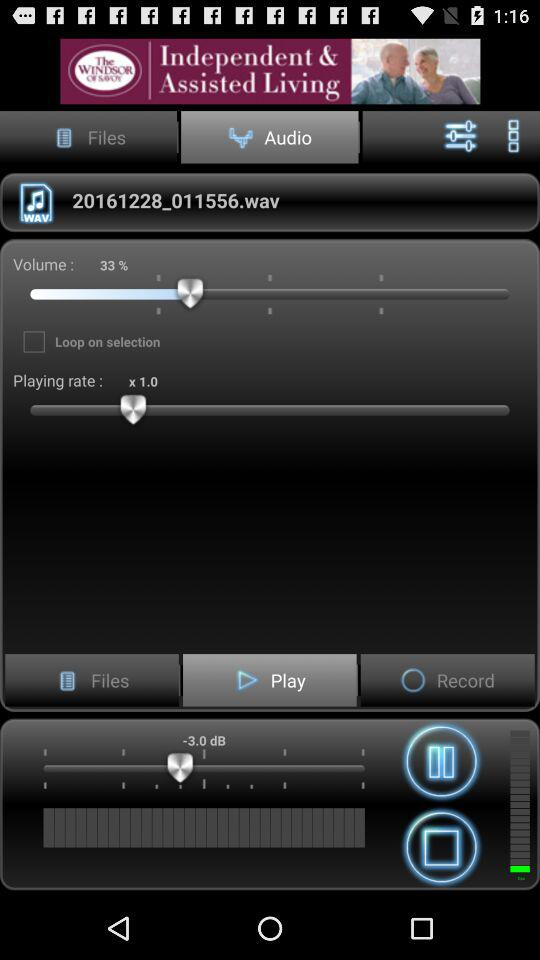What is the percentage of the volume? The percentage of the volume is 33. 